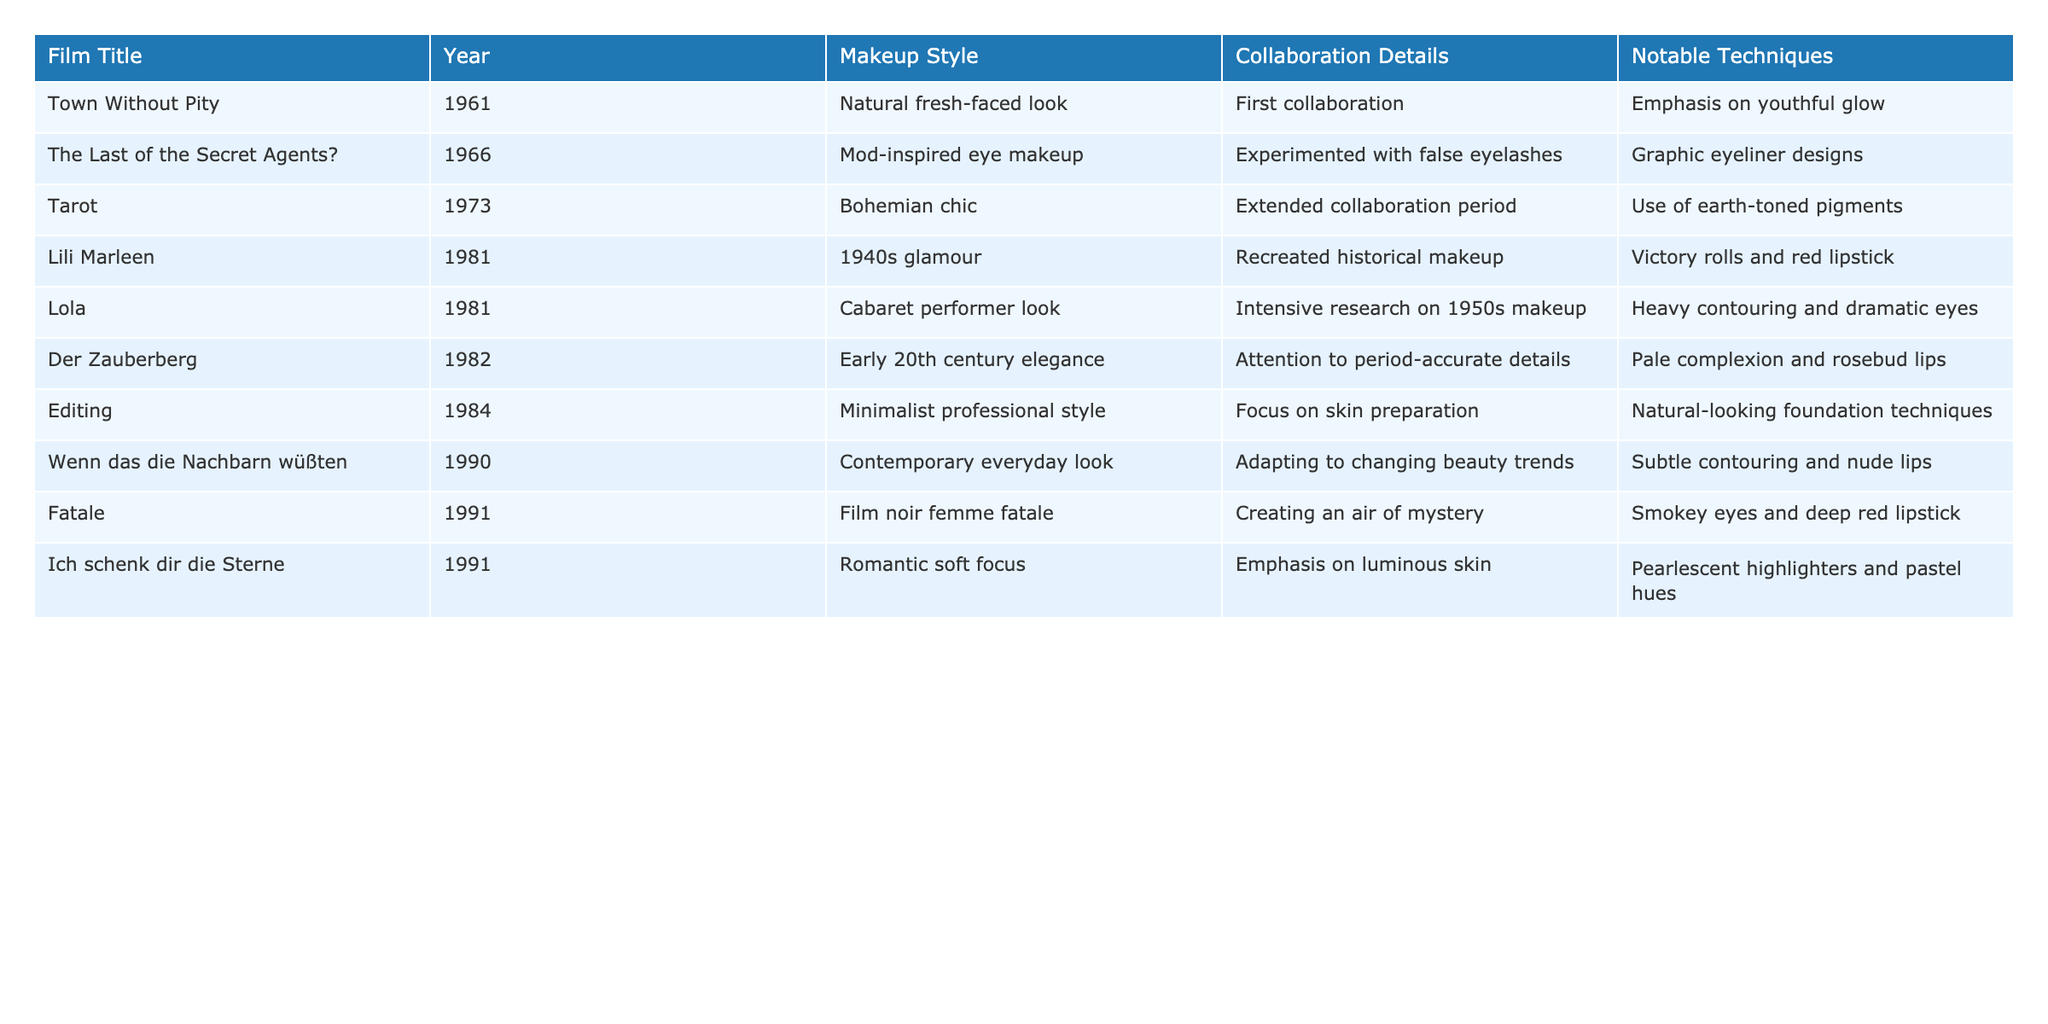What was Christine Kaufmann's first film collaboration? The first film collaboration listed in the table is "Town Without Pity," which was released in 1961.
Answer: Town Without Pity Which film features a makeup style inspired by the 1940s? The table shows that "Lili Marleen," released in 1981, features a 1940s glamour makeup style.
Answer: Lili Marleen How many films did Christine collaborate on that were made in the 1980s? By counting entries for the years 1980-1989, we find three films: "Lili Marleen," "Lola," and "Der Zauberberg," making the total three.
Answer: 3 Is there any film listed that uses natural-looking foundation techniques? Yes, the film "Editing," released in 1984, mentions a focus on skin preparation with natural-looking foundation techniques.
Answer: Yes What was the notable makeup technique used in the film "Fatale"? The notable technique used in "Fatale" (1991) is smokey eyes and deep red lipstick.
Answer: Smokey eyes and deep red lipstick Which movie had a makeup style reflecting contemporary everyday looks? The film "Wenn das die Nachbarn wüßten," released in 1990, features a contemporary everyday look.
Answer: Wenn das die Nachbarn wüßten How does the makeup style in "Tarot" differ from "Editing"? "Tarot" uses a bohemian chic makeup style, while "Editing" employs a minimalist professional style, indicating different approaches to aesthetics and visual impact.
Answer: They differ in aesthetic approach How many films featured heavy contouring as a notable technique? By reviewing the table, only "Lola" (1981) mentions heavy contouring as a notable technique. Thus, there is only one film.
Answer: 1 Which film represents an experimental approach with false eyelashes? The film "The Last of the Secret Agents?" from 1966 represents an experimental approach with false eyelashes.
Answer: The Last of the Secret Agents? What is the shared makeup technique used in both "Ich schenk dir die Sterne" and "Fatale"? Both films employ techniques that emphasize strong focal points: "Ich schenk dir die Sterne" uses pearlescent highlighters while "Fatale" features deep red lipstick, suggesting a focus on bold appearances.
Answer: Emphasis on bold appearances 